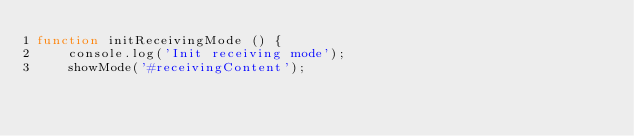Convert code to text. <code><loc_0><loc_0><loc_500><loc_500><_JavaScript_>function initReceivingMode () {
    console.log('Init receiving mode');
    showMode('#receivingContent');</code> 